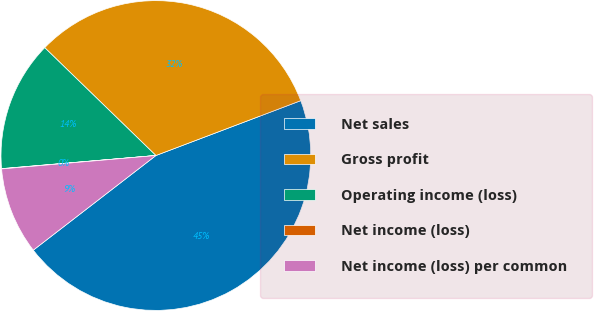<chart> <loc_0><loc_0><loc_500><loc_500><pie_chart><fcel>Net sales<fcel>Gross profit<fcel>Operating income (loss)<fcel>Net income (loss)<fcel>Net income (loss) per common<nl><fcel>45.3%<fcel>31.98%<fcel>13.61%<fcel>0.03%<fcel>9.08%<nl></chart> 